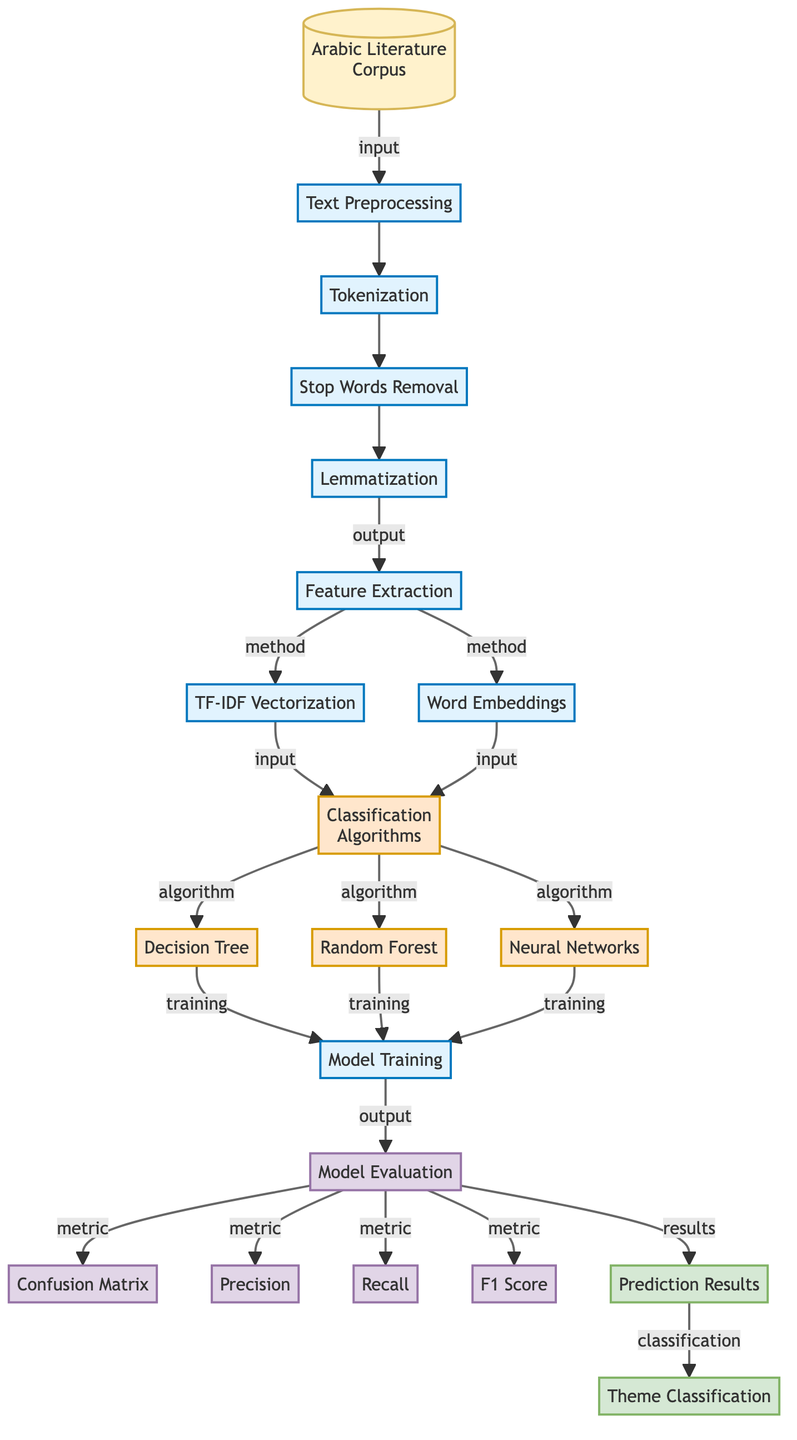What is the first step in the process after input? The diagram indicates that after the input, the first step is "Text Preprocessing." This is directly connected to the input node in the flowchart, showing it as the immediate next action.
Answer: Text Preprocessing How many classification algorithms are present in the diagram? The diagram lists three classification algorithms: Decision Tree, Random Forest, and Neural Networks. This can be counted directly from the nodes connected to the Classification Algorithms section.
Answer: Three Which step follows "Feature Extraction"? After "Feature Extraction," the next steps outlined in the diagram are "TF-IDF Vectorization" and "Word Embeddings." Both of these steps are derived from the output of the Feature Extraction node, indicating they occur simultaneously as part of the processing.
Answer: TF-IDF Vectorization and Word Embeddings What output is produced after Model Evaluation? The output produced after Model Evaluation is "Prediction Results" and "Theme Classification". These results are generated as a direct consequence of running the evaluation metrics, which measure the effectiveness of the model.
Answer: Prediction Results and Theme Classification What are the evaluation metrics used in this diagram? The evaluation metrics included in the diagram are Confusion Matrix, Precision, Recall, and F1 Score. Each metric is connected to the Model Evaluation node, indicating that they are all part of the evaluation process to assess the model's performance.
Answer: Confusion Matrix, Precision, Recall, and F1 Score Which step immediately precedes Model Evaluation? Immediately preceding Model Evaluation is "Model Training." The diagram illustrates that after training the models using the selected algorithms, the next step is to evaluate their performance.
Answer: Model Training What is the outcome of the step "Text Preprocessing"? The outcome of "Text Preprocessing" is "Feature Extraction." The arrow in the diagram shows that after preprocessing the text, it leads to the extraction of features from the prepared text data.
Answer: Feature Extraction Which classification algorithm is listed last in the diagram? The last classification algorithm listed in the diagram is "Neural Networks." This is identified by observing the order of algorithms presented in the section connected to classification algorithms.
Answer: Neural Networks 